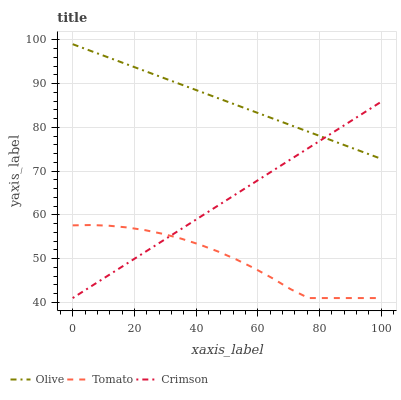Does Tomato have the minimum area under the curve?
Answer yes or no. Yes. Does Olive have the maximum area under the curve?
Answer yes or no. Yes. Does Crimson have the minimum area under the curve?
Answer yes or no. No. Does Crimson have the maximum area under the curve?
Answer yes or no. No. Is Crimson the smoothest?
Answer yes or no. Yes. Is Tomato the roughest?
Answer yes or no. Yes. Is Tomato the smoothest?
Answer yes or no. No. Is Crimson the roughest?
Answer yes or no. No. Does Crimson have the highest value?
Answer yes or no. No. Is Tomato less than Olive?
Answer yes or no. Yes. Is Olive greater than Tomato?
Answer yes or no. Yes. Does Tomato intersect Olive?
Answer yes or no. No. 